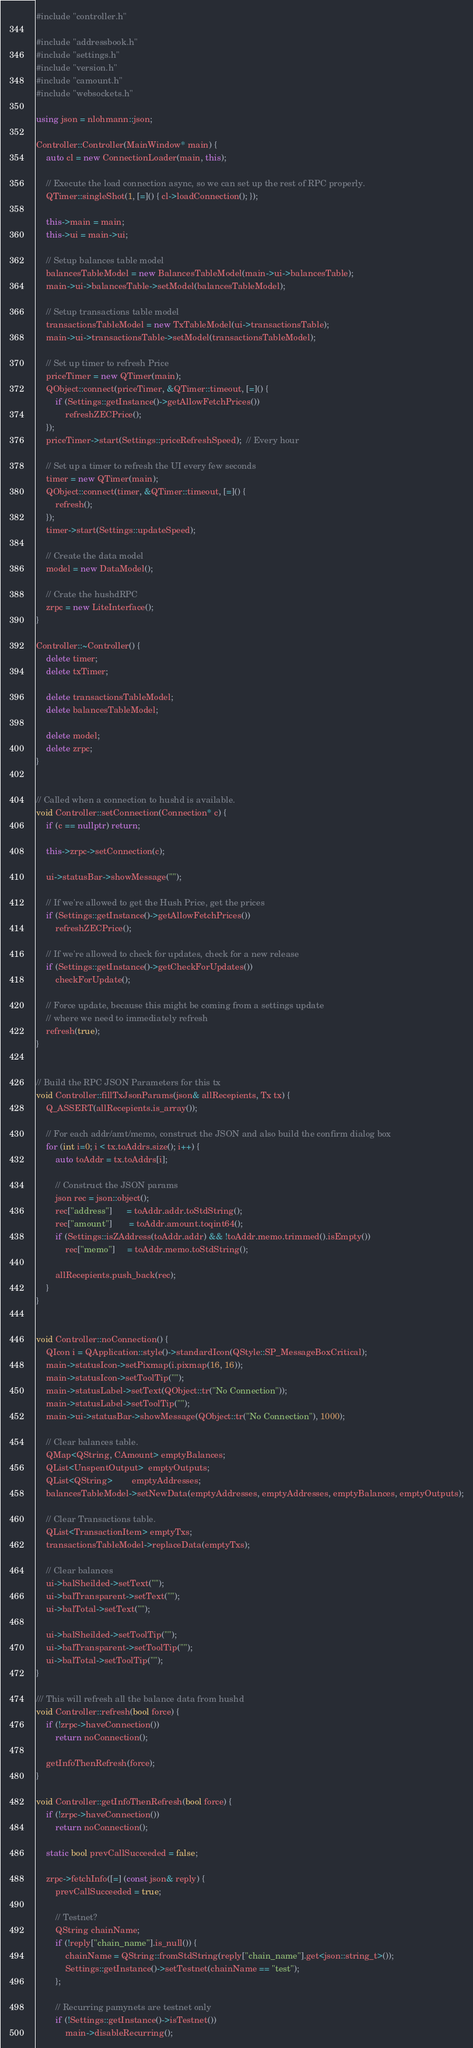<code> <loc_0><loc_0><loc_500><loc_500><_C++_>#include "controller.h"

#include "addressbook.h"
#include "settings.h"
#include "version.h"
#include "camount.h"
#include "websockets.h"

using json = nlohmann::json;

Controller::Controller(MainWindow* main) {
    auto cl = new ConnectionLoader(main, this);

    // Execute the load connection async, so we can set up the rest of RPC properly. 
    QTimer::singleShot(1, [=]() { cl->loadConnection(); });

    this->main = main;
    this->ui = main->ui;

    // Setup balances table model
    balancesTableModel = new BalancesTableModel(main->ui->balancesTable);
    main->ui->balancesTable->setModel(balancesTableModel);

    // Setup transactions table model
    transactionsTableModel = new TxTableModel(ui->transactionsTable);
    main->ui->transactionsTable->setModel(transactionsTableModel);
    
    // Set up timer to refresh Price
    priceTimer = new QTimer(main);
    QObject::connect(priceTimer, &QTimer::timeout, [=]() {
        if (Settings::getInstance()->getAllowFetchPrices())
            refreshZECPrice();
    });
    priceTimer->start(Settings::priceRefreshSpeed);  // Every hour

    // Set up a timer to refresh the UI every few seconds
    timer = new QTimer(main);
    QObject::connect(timer, &QTimer::timeout, [=]() {
        refresh();
    });
    timer->start(Settings::updateSpeed);    

    // Create the data model
    model = new DataModel();

    // Crate the hushdRPC 
    zrpc = new LiteInterface();
}

Controller::~Controller() {
    delete timer;
    delete txTimer;

    delete transactionsTableModel;
    delete balancesTableModel;

    delete model;
    delete zrpc;
}


// Called when a connection to hushd is available. 
void Controller::setConnection(Connection* c) {
    if (c == nullptr) return;

    this->zrpc->setConnection(c);

    ui->statusBar->showMessage("");

    // If we're allowed to get the Hush Price, get the prices
    if (Settings::getInstance()->getAllowFetchPrices())
        refreshZECPrice();

    // If we're allowed to check for updates, check for a new release
    if (Settings::getInstance()->getCheckForUpdates())
        checkForUpdate();

    // Force update, because this might be coming from a settings update
    // where we need to immediately refresh
    refresh(true);
}


// Build the RPC JSON Parameters for this tx
void Controller::fillTxJsonParams(json& allRecepients, Tx tx) {   
    Q_ASSERT(allRecepients.is_array());

    // For each addr/amt/memo, construct the JSON and also build the confirm dialog box    
    for (int i=0; i < tx.toAddrs.size(); i++) {
        auto toAddr = tx.toAddrs[i];

        // Construct the JSON params
        json rec = json::object();
        rec["address"]      = toAddr.addr.toStdString();
        rec["amount"]       = toAddr.amount.toqint64();
        if (Settings::isZAddress(toAddr.addr) && !toAddr.memo.trimmed().isEmpty())
            rec["memo"]     = toAddr.memo.toStdString();

        allRecepients.push_back(rec);
    }
}


void Controller::noConnection() {    
    QIcon i = QApplication::style()->standardIcon(QStyle::SP_MessageBoxCritical);
    main->statusIcon->setPixmap(i.pixmap(16, 16));
    main->statusIcon->setToolTip("");
    main->statusLabel->setText(QObject::tr("No Connection"));
    main->statusLabel->setToolTip("");
    main->ui->statusBar->showMessage(QObject::tr("No Connection"), 1000);

    // Clear balances table.
    QMap<QString, CAmount> emptyBalances;
    QList<UnspentOutput>  emptyOutputs;
    QList<QString>        emptyAddresses;
    balancesTableModel->setNewData(emptyAddresses, emptyAddresses, emptyBalances, emptyOutputs);

    // Clear Transactions table.
    QList<TransactionItem> emptyTxs;
    transactionsTableModel->replaceData(emptyTxs);

    // Clear balances
    ui->balSheilded->setText("");
    ui->balTransparent->setText("");
    ui->balTotal->setText("");

    ui->balSheilded->setToolTip("");
    ui->balTransparent->setToolTip("");
    ui->balTotal->setToolTip("");
}

/// This will refresh all the balance data from hushd
void Controller::refresh(bool force) {
    if (!zrpc->haveConnection()) 
        return noConnection();

    getInfoThenRefresh(force);
}

void Controller::getInfoThenRefresh(bool force) {
    if (!zrpc->haveConnection()) 
        return noConnection();

    static bool prevCallSucceeded = false;

    zrpc->fetchInfo([=] (const json& reply) {   
        prevCallSucceeded = true;

        // Testnet?
        QString chainName;
        if (!reply["chain_name"].is_null()) {
            chainName = QString::fromStdString(reply["chain_name"].get<json::string_t>());
            Settings::getInstance()->setTestnet(chainName == "test");
        };

        // Recurring pamynets are testnet only
        if (!Settings::getInstance()->isTestnet())
            main->disableRecurring();
</code> 